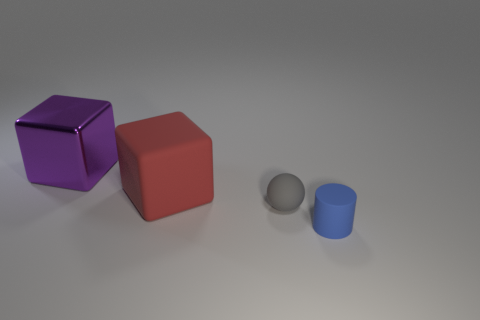What time of day or lighting conditions does this image seem to represent? The image appears to be taken under artificial lighting conditions rather than natural outdoor lighting. The soft shadows and the even distribution of light on the objects suggest an indoor setting with diffuse, overhead lighting, typical of a studio environment. 